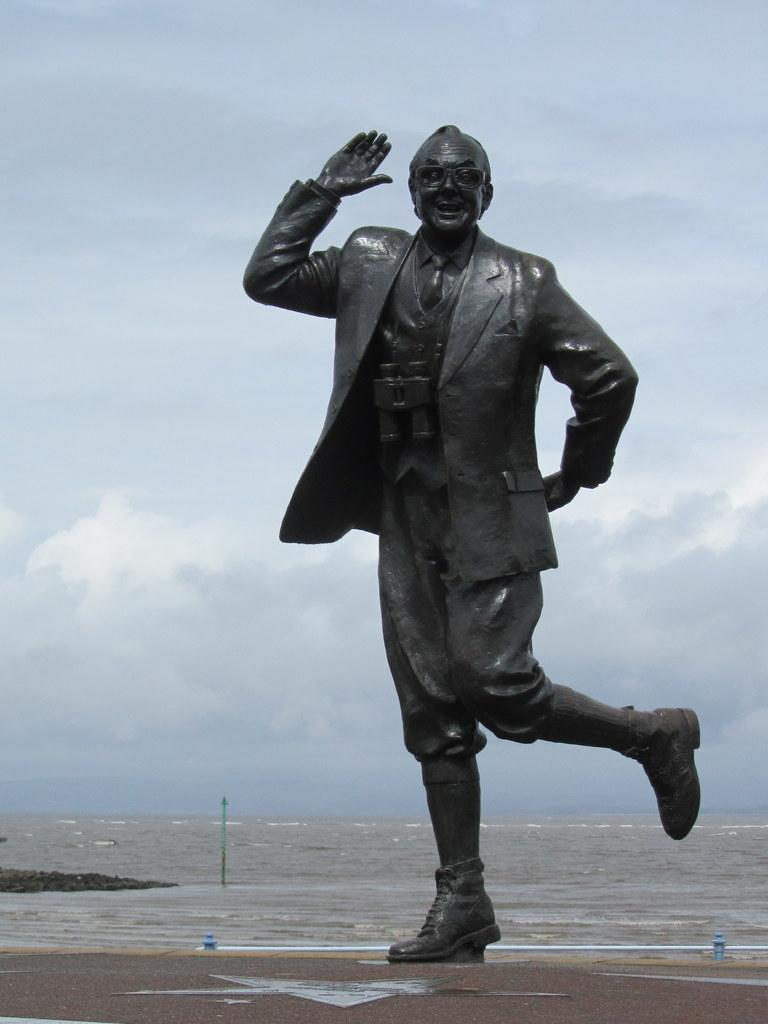What is the main subject in the image? There is a statue in the image. What natural feature can be seen in the image? There is a sea in the image. What can be found on the ground in the image? There are objects on the ground in the image. How would you describe the sky in the image? The sky is cloudy in the image. What type of detail can be seen on the carriage in the image? There is no carriage present in the image; it only features a statue, sea, objects on the ground, and a cloudy sky. 